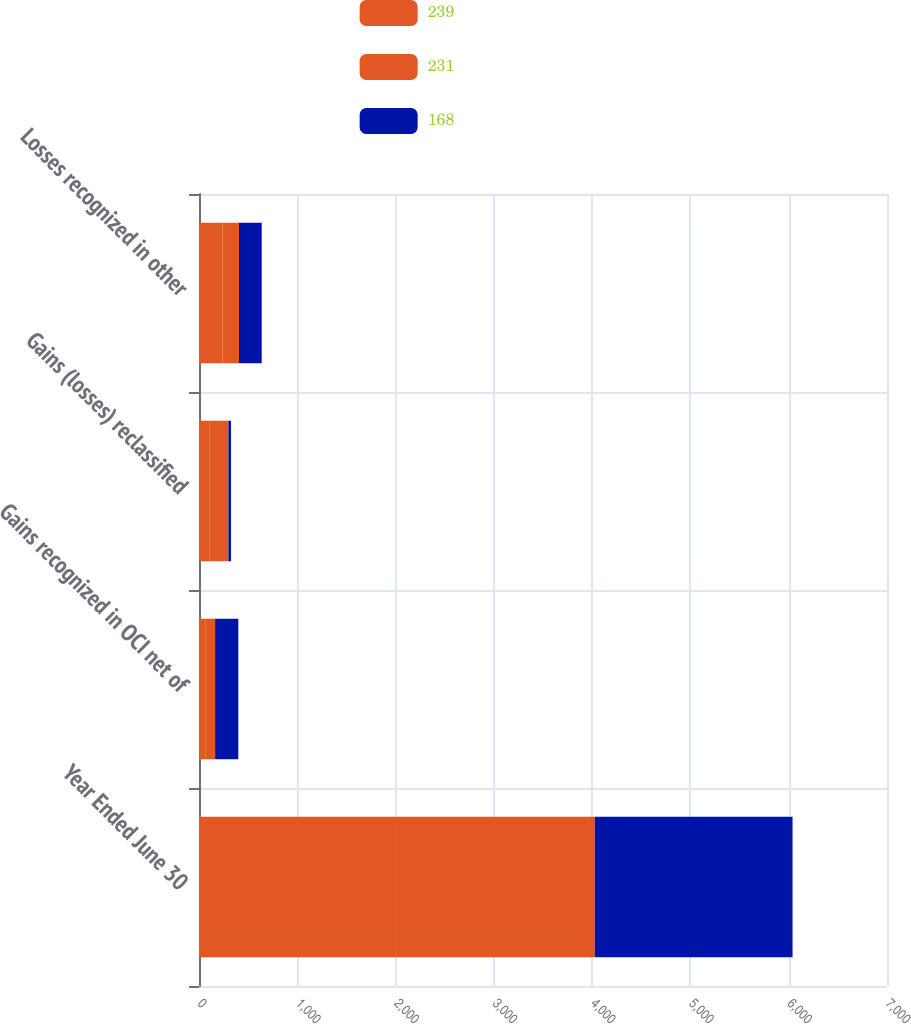Convert chart. <chart><loc_0><loc_0><loc_500><loc_500><stacked_bar_chart><ecel><fcel>Year Ended June 30<fcel>Gains recognized in OCI net of<fcel>Gains (losses) reclassified<fcel>Losses recognized in other<nl><fcel>239<fcel>2014<fcel>63<fcel>104<fcel>239<nl><fcel>231<fcel>2013<fcel>101<fcel>195<fcel>168<nl><fcel>168<fcel>2012<fcel>236<fcel>27<fcel>231<nl></chart> 